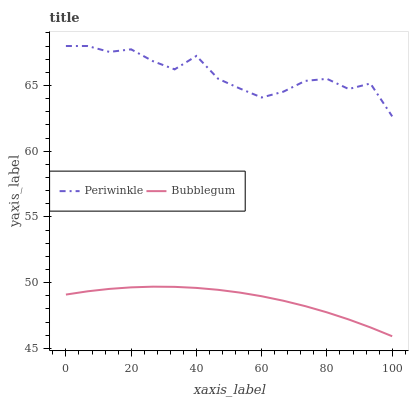Does Bubblegum have the minimum area under the curve?
Answer yes or no. Yes. Does Periwinkle have the maximum area under the curve?
Answer yes or no. Yes. Does Bubblegum have the maximum area under the curve?
Answer yes or no. No. Is Bubblegum the smoothest?
Answer yes or no. Yes. Is Periwinkle the roughest?
Answer yes or no. Yes. Is Bubblegum the roughest?
Answer yes or no. No. Does Bubblegum have the lowest value?
Answer yes or no. Yes. Does Periwinkle have the highest value?
Answer yes or no. Yes. Does Bubblegum have the highest value?
Answer yes or no. No. Is Bubblegum less than Periwinkle?
Answer yes or no. Yes. Is Periwinkle greater than Bubblegum?
Answer yes or no. Yes. Does Bubblegum intersect Periwinkle?
Answer yes or no. No. 